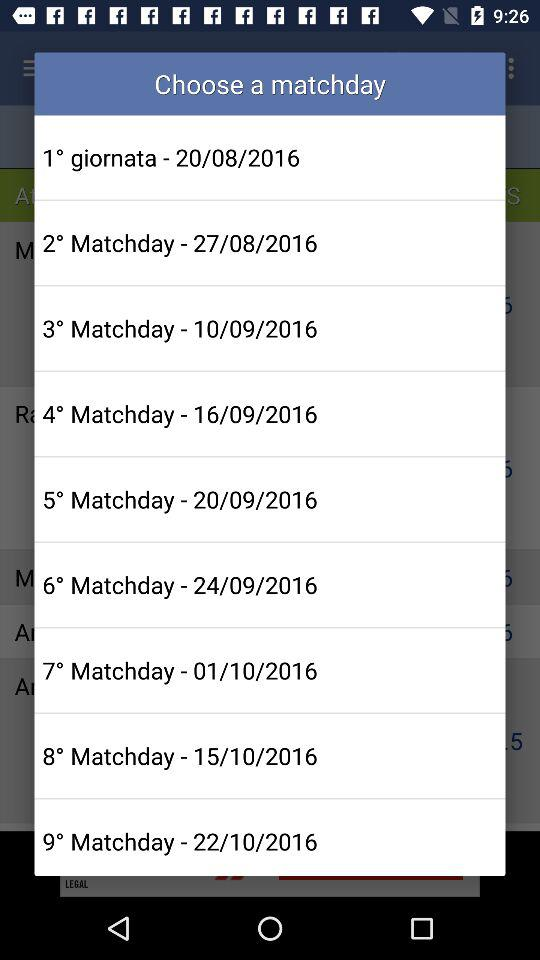On what date is the "9° Matchday"? The date is October 22, 2016. 